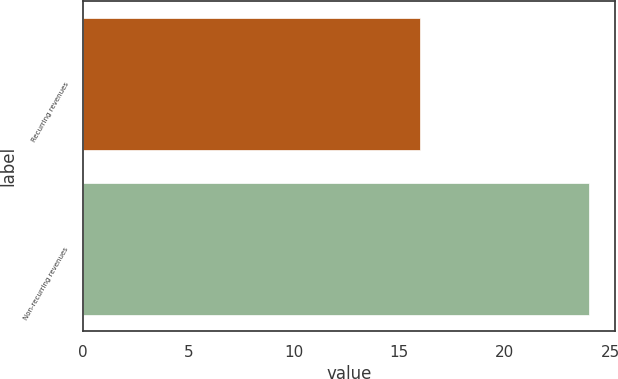Convert chart. <chart><loc_0><loc_0><loc_500><loc_500><bar_chart><fcel>Recurring revenues<fcel>Non-recurring revenues<nl><fcel>16<fcel>24<nl></chart> 